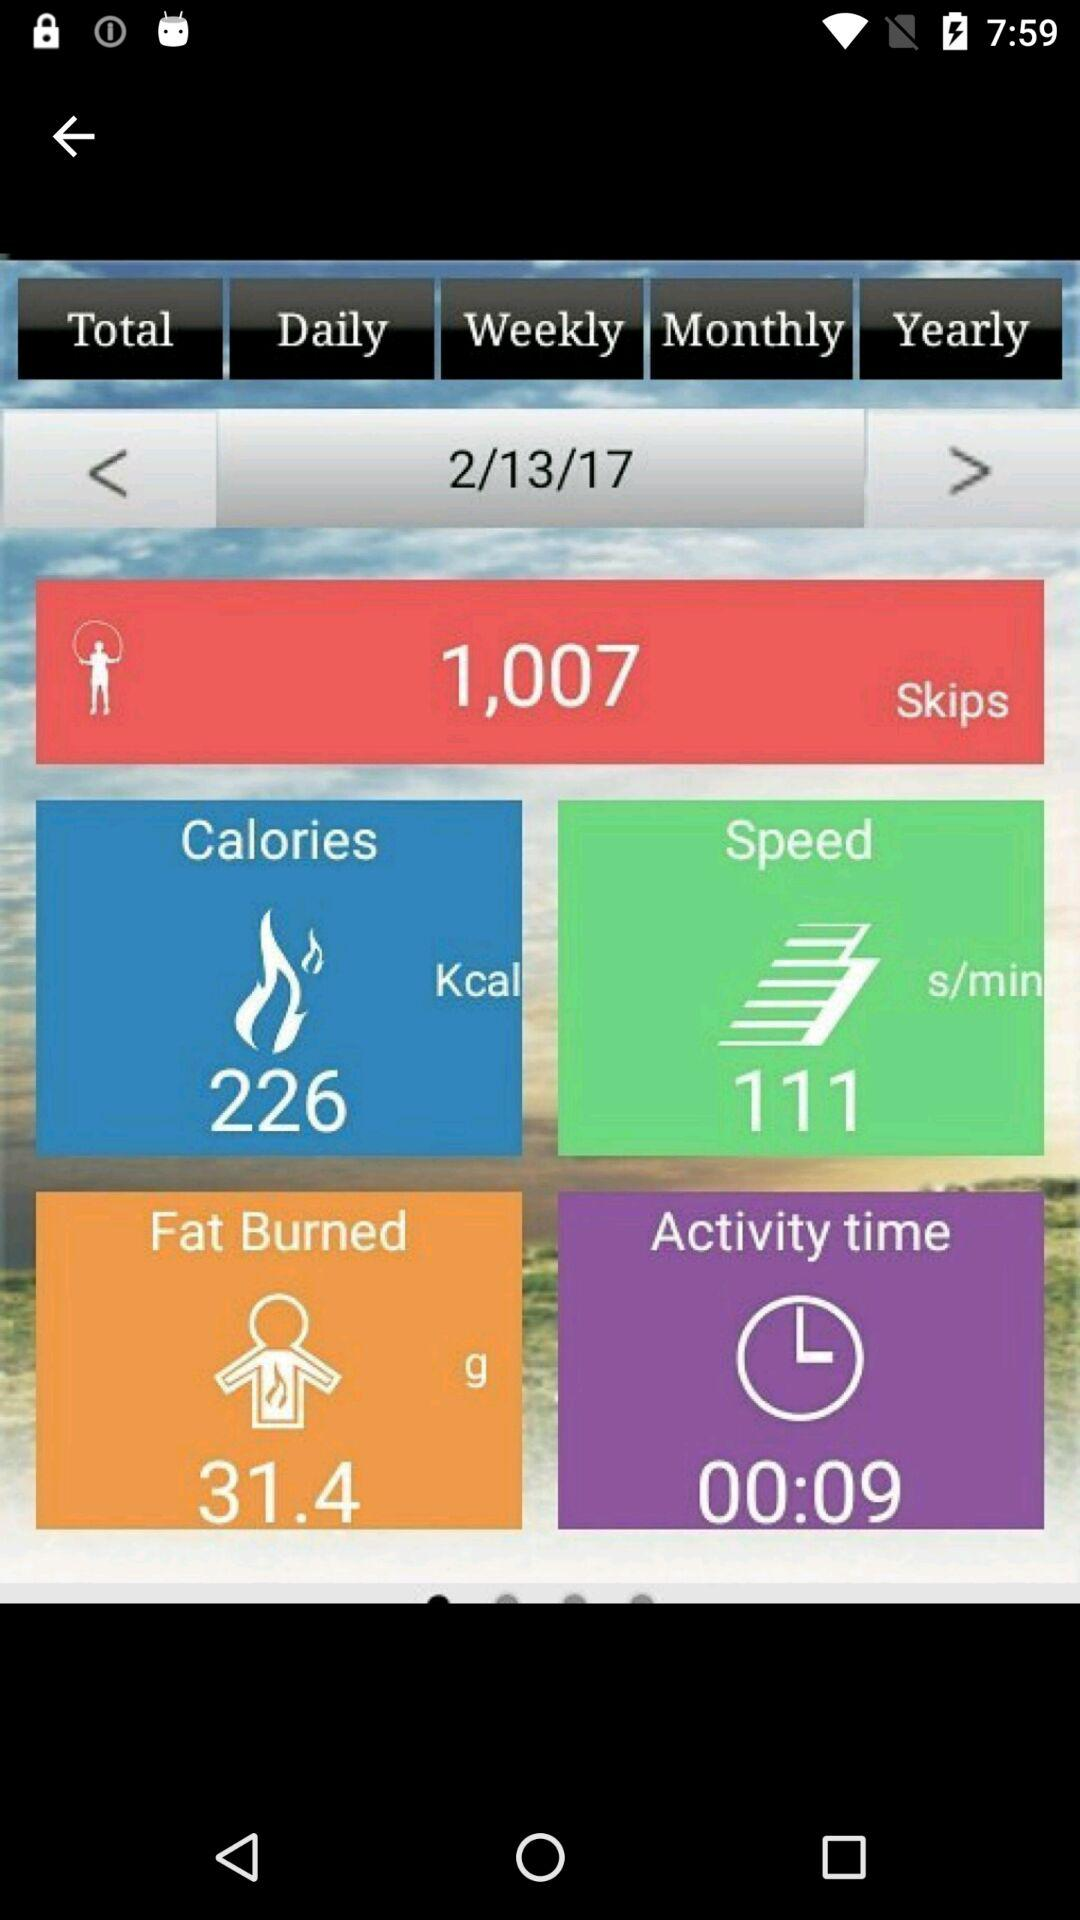How many skips are taken on 2/13/17? There are 1,007 skips taken on February 13, 2017. 